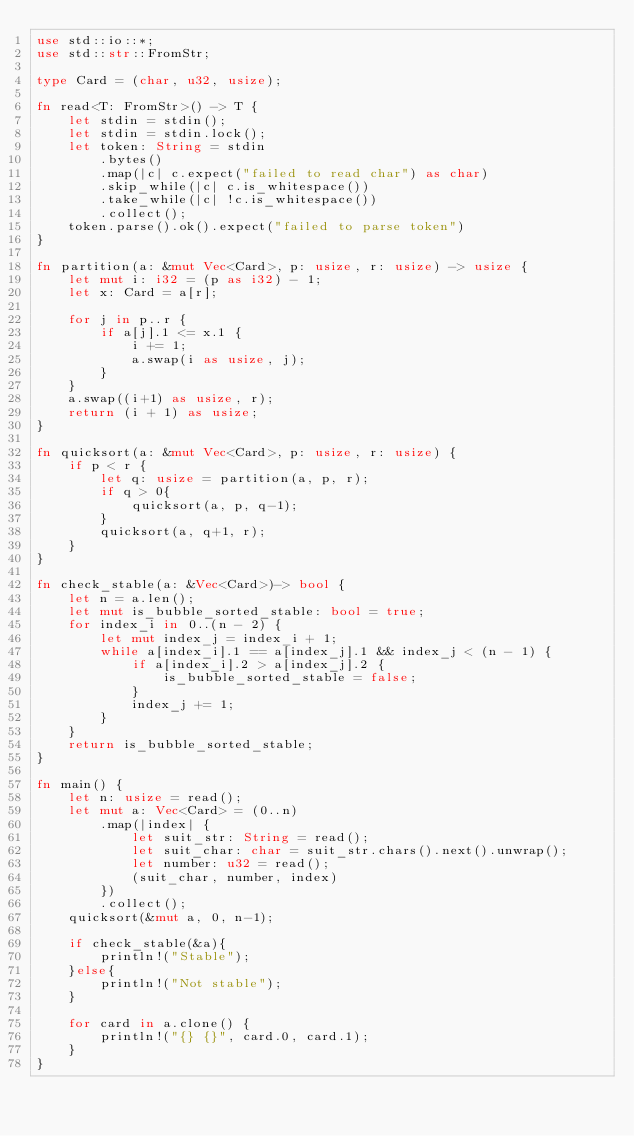<code> <loc_0><loc_0><loc_500><loc_500><_Rust_>use std::io::*;
use std::str::FromStr;

type Card = (char, u32, usize);

fn read<T: FromStr>() -> T {
    let stdin = stdin();
    let stdin = stdin.lock();
    let token: String = stdin
        .bytes()
        .map(|c| c.expect("failed to read char") as char)
        .skip_while(|c| c.is_whitespace())
        .take_while(|c| !c.is_whitespace())
        .collect();
    token.parse().ok().expect("failed to parse token")
}

fn partition(a: &mut Vec<Card>, p: usize, r: usize) -> usize {
    let mut i: i32 = (p as i32) - 1;
    let x: Card = a[r];

    for j in p..r {
        if a[j].1 <= x.1 {
            i += 1;
            a.swap(i as usize, j);
        }
    }
    a.swap((i+1) as usize, r);
    return (i + 1) as usize;
}

fn quicksort(a: &mut Vec<Card>, p: usize, r: usize) {
    if p < r {
        let q: usize = partition(a, p, r);
        if q > 0{
            quicksort(a, p, q-1);
        }
        quicksort(a, q+1, r);
    }
}

fn check_stable(a: &Vec<Card>)-> bool {
    let n = a.len();
    let mut is_bubble_sorted_stable: bool = true;
    for index_i in 0..(n - 2) {
        let mut index_j = index_i + 1;
        while a[index_i].1 == a[index_j].1 && index_j < (n - 1) {
            if a[index_i].2 > a[index_j].2 {
                is_bubble_sorted_stable = false;
            }
            index_j += 1;
        }
    }
    return is_bubble_sorted_stable;
}

fn main() {
    let n: usize = read();
    let mut a: Vec<Card> = (0..n)
        .map(|index| {
            let suit_str: String = read();
            let suit_char: char = suit_str.chars().next().unwrap();
            let number: u32 = read();
            (suit_char, number, index)
        })
        .collect();
    quicksort(&mut a, 0, n-1);

    if check_stable(&a){
        println!("Stable");
    }else{
        println!("Not stable");
    }

    for card in a.clone() {
        println!("{} {}", card.0, card.1);
    }
}

</code> 